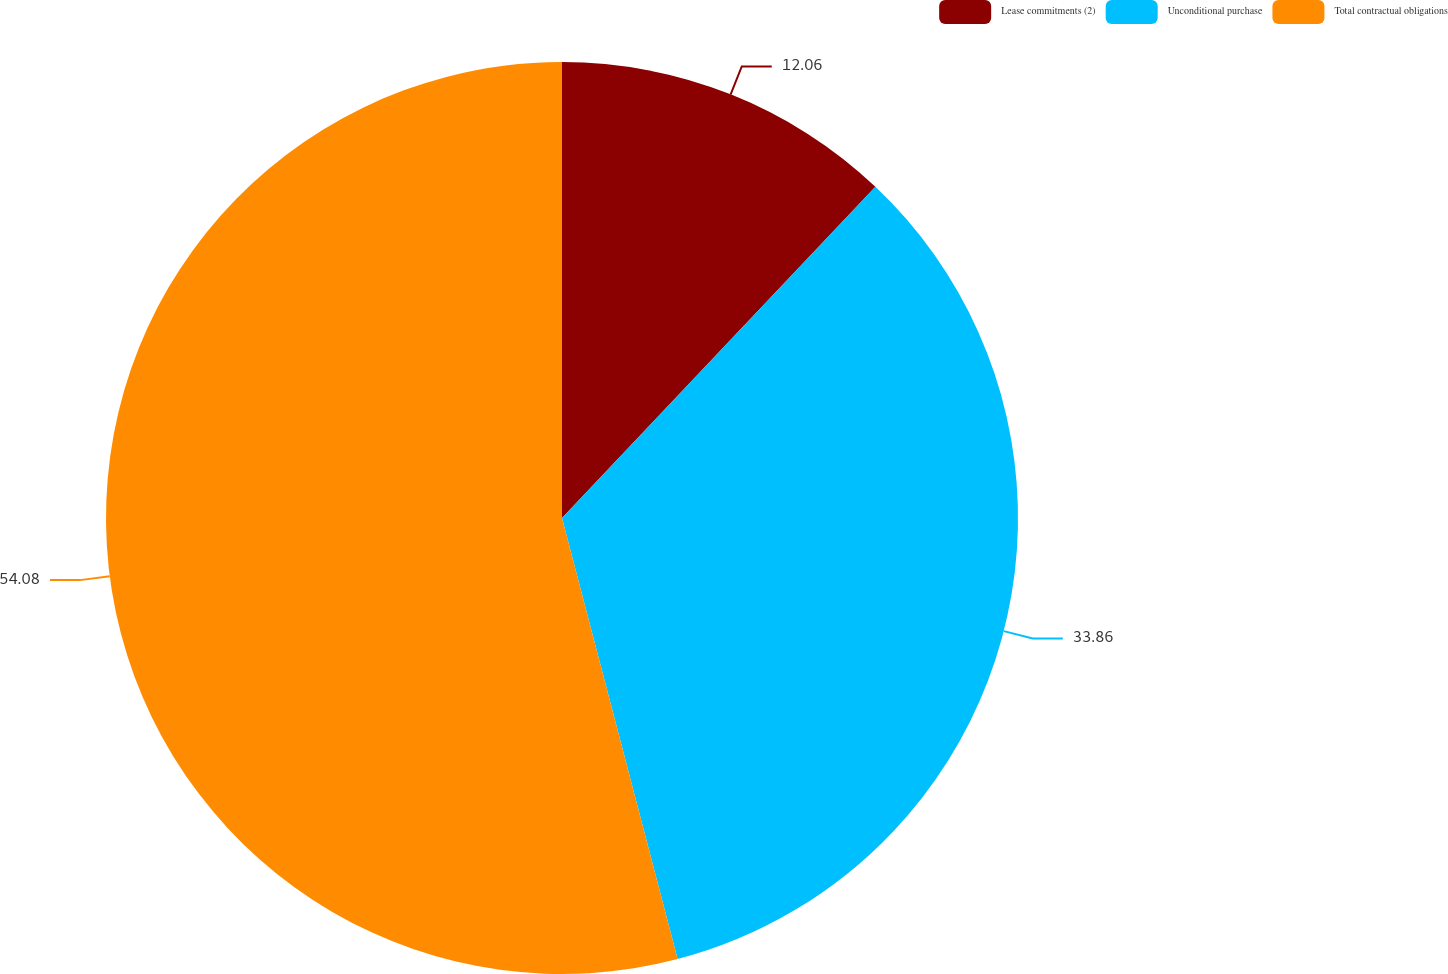<chart> <loc_0><loc_0><loc_500><loc_500><pie_chart><fcel>Lease commitments (2)<fcel>Unconditional purchase<fcel>Total contractual obligations<nl><fcel>12.06%<fcel>33.86%<fcel>54.08%<nl></chart> 